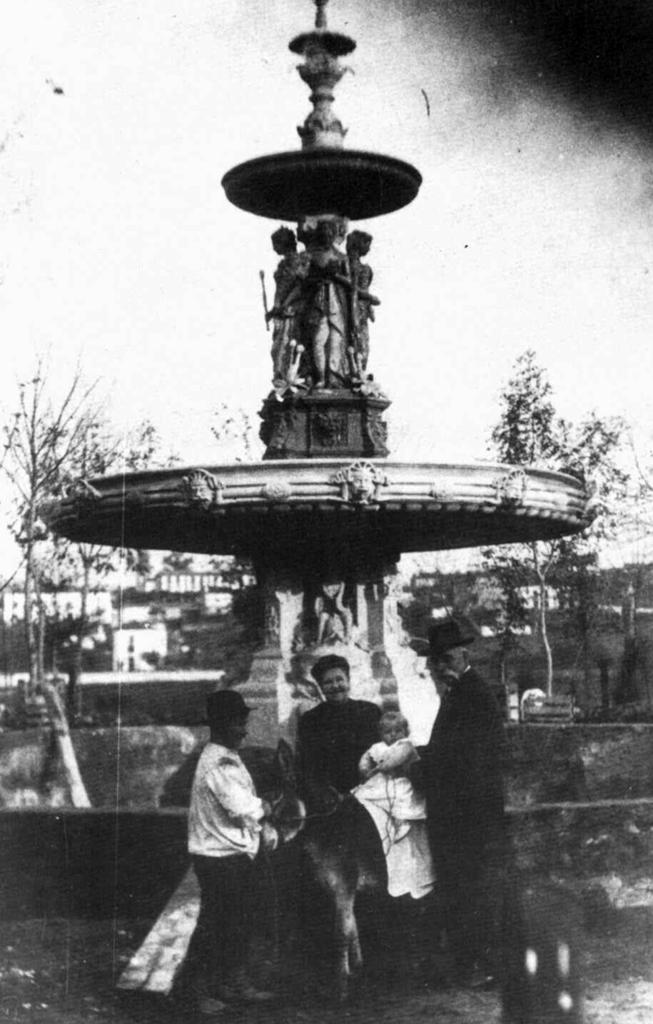What is the color scheme of the image? The image is black and white. What types of subjects can be seen in the image? There are persons, statues, trees, and buildings in the image. What is visible in the background of the image? The sky is visible in the background of the image. Can you read the note that is being held by the statue in the image? There is no note present in the image; the statue does not have any object in its hands. 